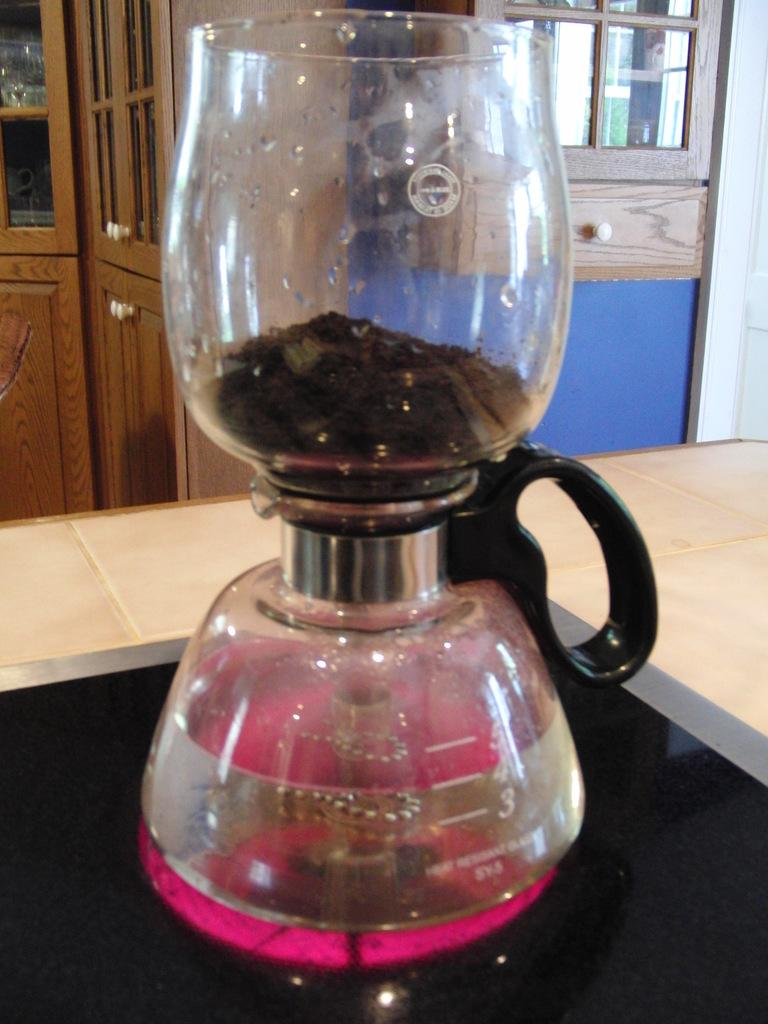What type of coffee maker is in the image? There is a vacuum coffee maker in the image. What is the color of the surface the vacuum coffee maker is on? The vacuum coffee maker is on a black surface. What type of floor is visible in the image? There is a floor visible in the image. What type of door can be seen in the image? There is a door with glass windows in the image. What type of tank is visible in the image? There is no tank present in the image. What does the person in the image regret? There is no person present in the image, so it is impossible to determine if they have any regrets. 